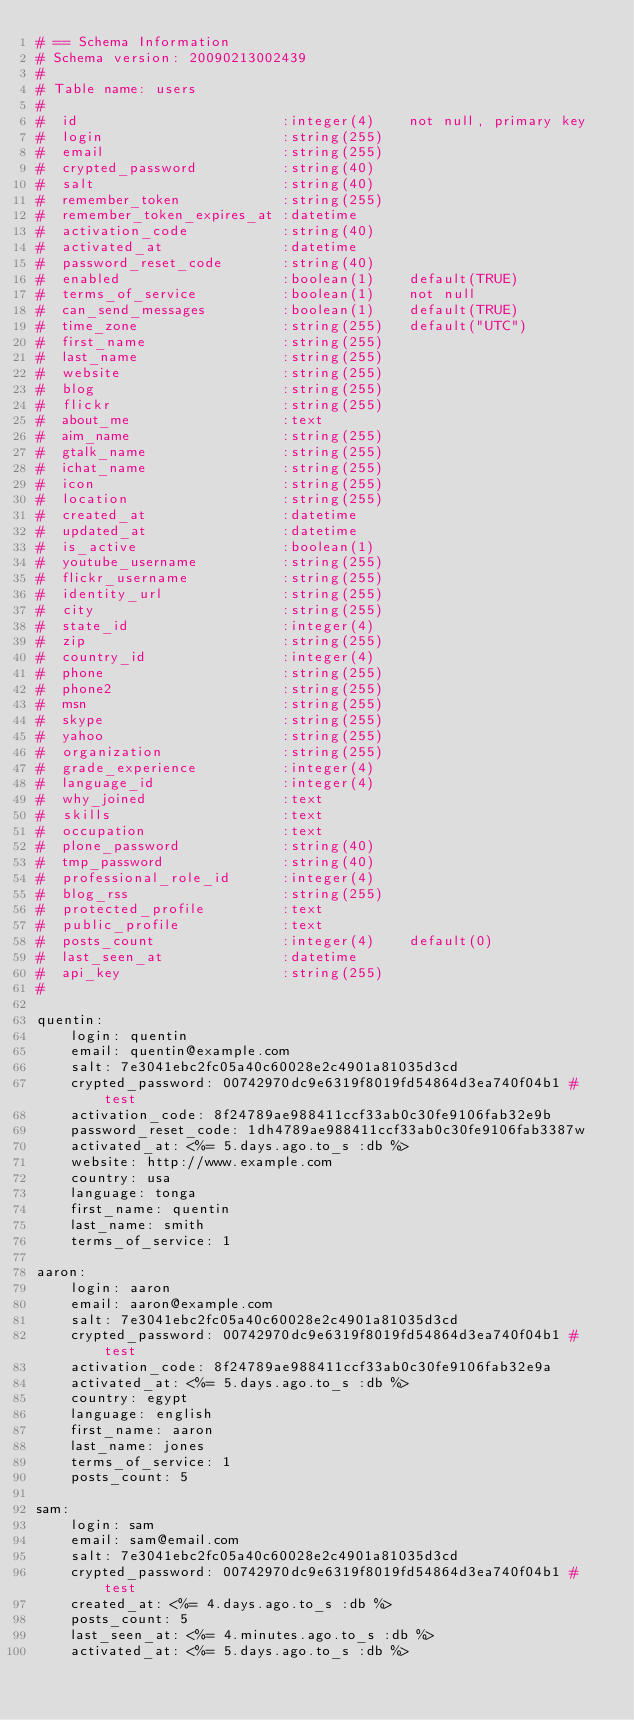<code> <loc_0><loc_0><loc_500><loc_500><_YAML_># == Schema Information
# Schema version: 20090213002439
#
# Table name: users
#
#  id                        :integer(4)    not null, primary key
#  login                     :string(255)   
#  email                     :string(255)   
#  crypted_password          :string(40)    
#  salt                      :string(40)    
#  remember_token            :string(255)   
#  remember_token_expires_at :datetime      
#  activation_code           :string(40)    
#  activated_at              :datetime      
#  password_reset_code       :string(40)    
#  enabled                   :boolean(1)    default(TRUE)
#  terms_of_service          :boolean(1)    not null
#  can_send_messages         :boolean(1)    default(TRUE)
#  time_zone                 :string(255)   default("UTC")
#  first_name                :string(255)   
#  last_name                 :string(255)   
#  website                   :string(255)   
#  blog                      :string(255)   
#  flickr                    :string(255)   
#  about_me                  :text          
#  aim_name                  :string(255)   
#  gtalk_name                :string(255)   
#  ichat_name                :string(255)   
#  icon                      :string(255)   
#  location                  :string(255)   
#  created_at                :datetime      
#  updated_at                :datetime      
#  is_active                 :boolean(1)    
#  youtube_username          :string(255)   
#  flickr_username           :string(255)   
#  identity_url              :string(255)   
#  city                      :string(255)   
#  state_id                  :integer(4)    
#  zip                       :string(255)   
#  country_id                :integer(4)    
#  phone                     :string(255)   
#  phone2                    :string(255)   
#  msn                       :string(255)   
#  skype                     :string(255)   
#  yahoo                     :string(255)   
#  organization              :string(255)   
#  grade_experience          :integer(4)    
#  language_id               :integer(4)    
#  why_joined                :text          
#  skills                    :text          
#  occupation                :text          
#  plone_password            :string(40)    
#  tmp_password              :string(40)    
#  professional_role_id      :integer(4)    
#  blog_rss                  :string(255)   
#  protected_profile         :text          
#  public_profile            :text          
#  posts_count               :integer(4)    default(0)
#  last_seen_at              :datetime      
#  api_key                   :string(255)   
#

quentin:
    login: quentin
    email: quentin@example.com
    salt: 7e3041ebc2fc05a40c60028e2c4901a81035d3cd
    crypted_password: 00742970dc9e6319f8019fd54864d3ea740f04b1 # test
    activation_code: 8f24789ae988411ccf33ab0c30fe9106fab32e9b 
    password_reset_code: 1dh4789ae988411ccf33ab0c30fe9106fab3387w
    activated_at: <%= 5.days.ago.to_s :db %> 
    website: http://www.example.com
    country: usa
    language: tonga
    first_name: quentin
    last_name: smith
    terms_of_service: 1
    
aaron:
    login: aaron
    email: aaron@example.com
    salt: 7e3041ebc2fc05a40c60028e2c4901a81035d3cd
    crypted_password: 00742970dc9e6319f8019fd54864d3ea740f04b1 # test
    activation_code: 8f24789ae988411ccf33ab0c30fe9106fab32e9a
    activated_at: <%= 5.days.ago.to_s :db %>
    country: egypt
    language: english
    first_name: aaron
    last_name: jones
    terms_of_service: 1
    posts_count: 5

sam:
    login: sam
    email: sam@email.com
    salt: 7e3041ebc2fc05a40c60028e2c4901a81035d3cd
    crypted_password: 00742970dc9e6319f8019fd54864d3ea740f04b1 # test
    created_at: <%= 4.days.ago.to_s :db %>
    posts_count: 5
    last_seen_at: <%= 4.minutes.ago.to_s :db %>
    activated_at: <%= 5.days.ago.to_s :db %></code> 